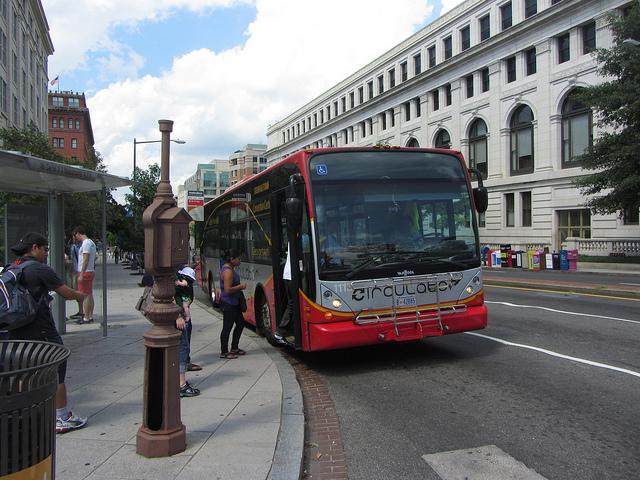How many people are boarding the bus?
Answer briefly. 1. Is the woman in a sari?
Write a very short answer. No. Where could a person throw away their trash?
Answer briefly. Trash can. What color is the bus, besides red?
Short answer required. Gray. Is anyone getting on the bus?
Short answer required. Yes. 